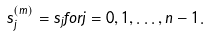<formula> <loc_0><loc_0><loc_500><loc_500>s _ { j } ^ { ( m ) } = s _ { j } f o r j = 0 , 1 , \dots , n - 1 .</formula> 